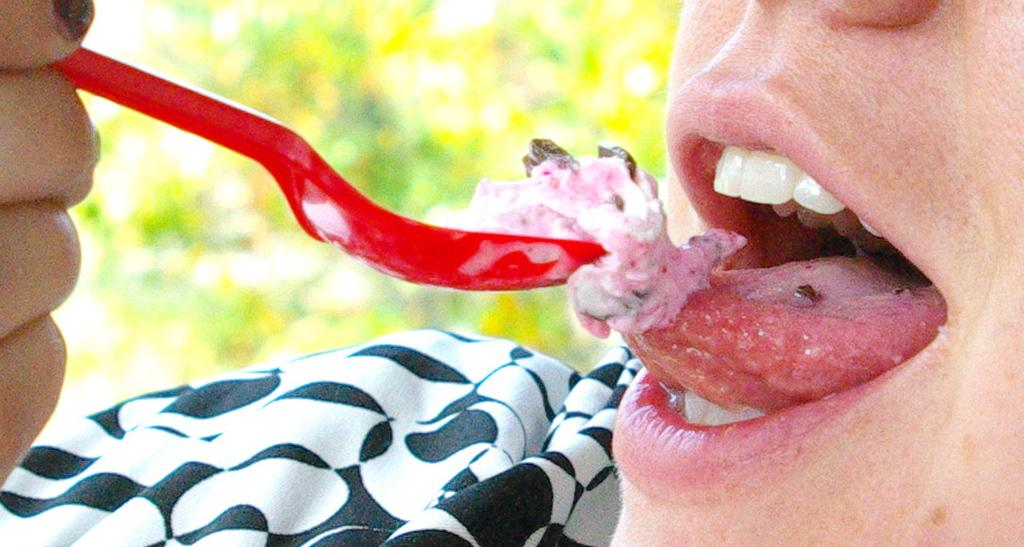Who is the main subject in the image? There is a person in the image. What is the person doing in the image? The person is eating ice cream. What color is the spoon the person is using? The person is using a red spoon. Can you describe the background of the image? The background of the image is blurred. What type of muscle is the person exercising in the image? There is no indication in the image that the person is exercising any muscles, as they are eating ice cream. 